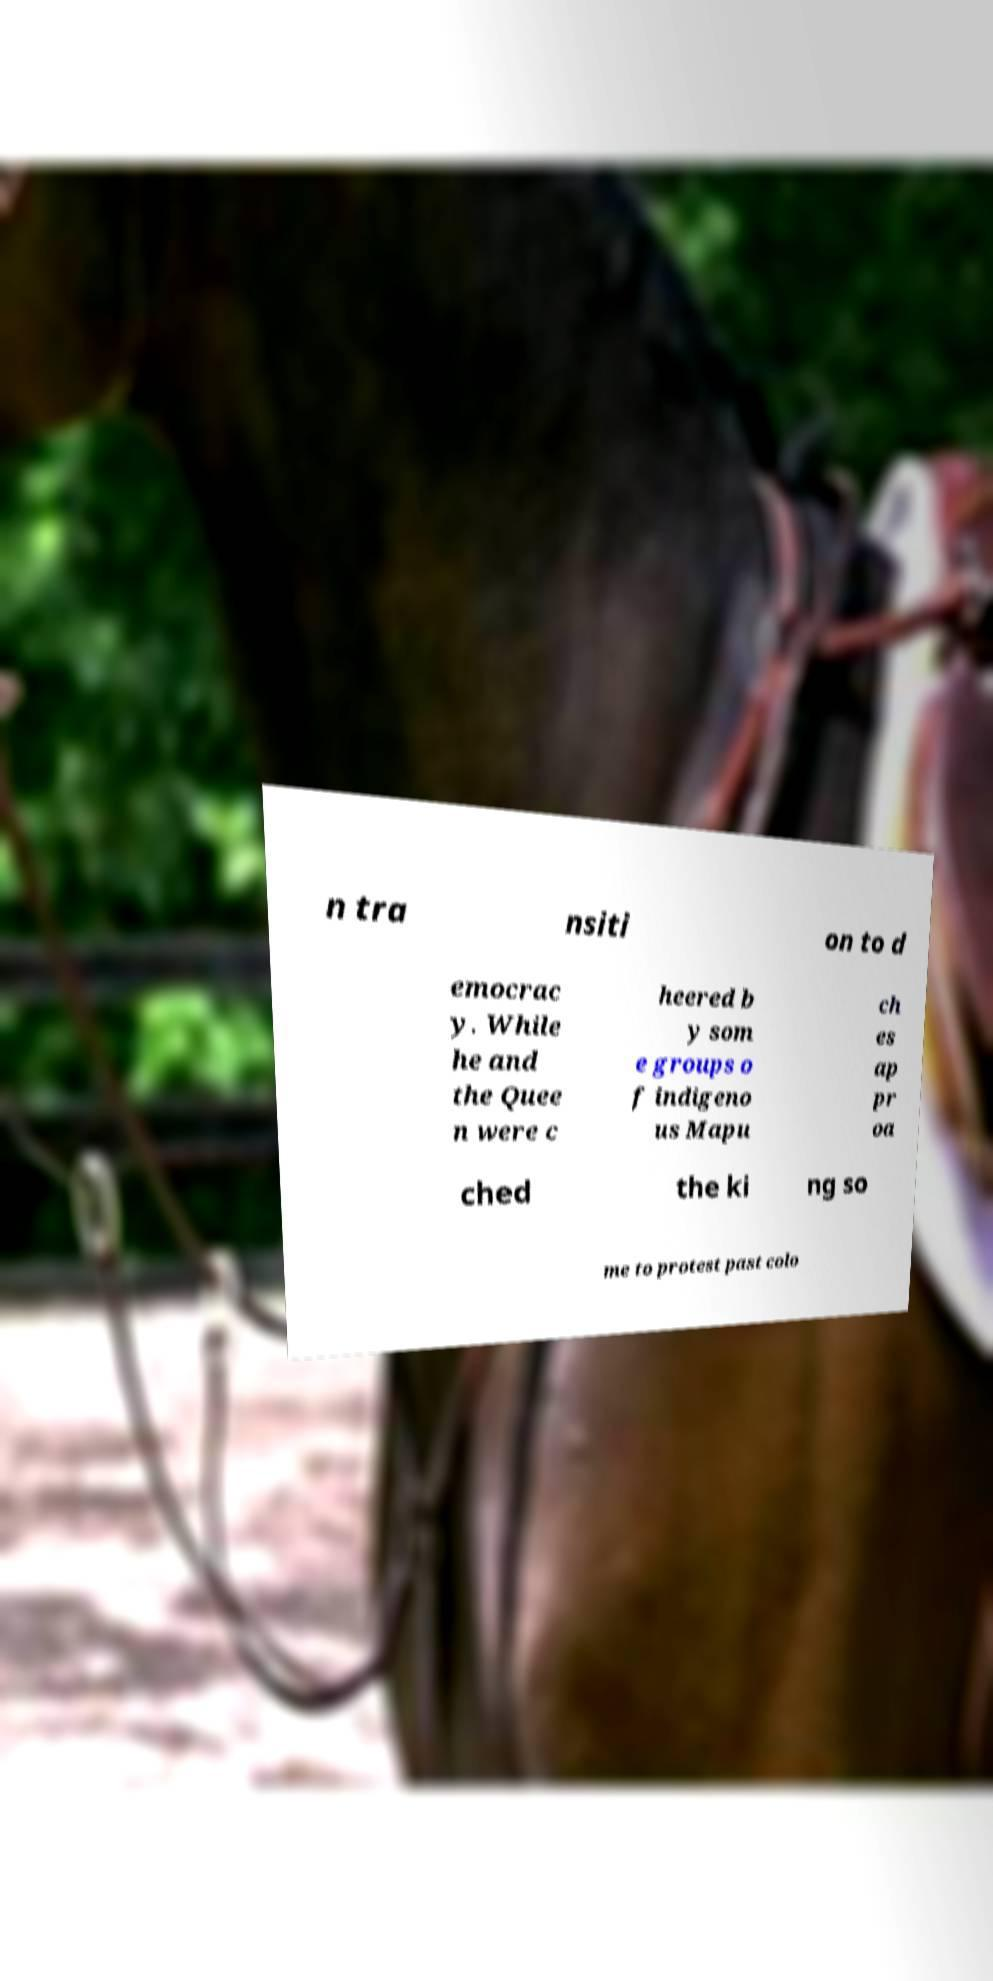I need the written content from this picture converted into text. Can you do that? n tra nsiti on to d emocrac y. While he and the Quee n were c heered b y som e groups o f indigeno us Mapu ch es ap pr oa ched the ki ng so me to protest past colo 